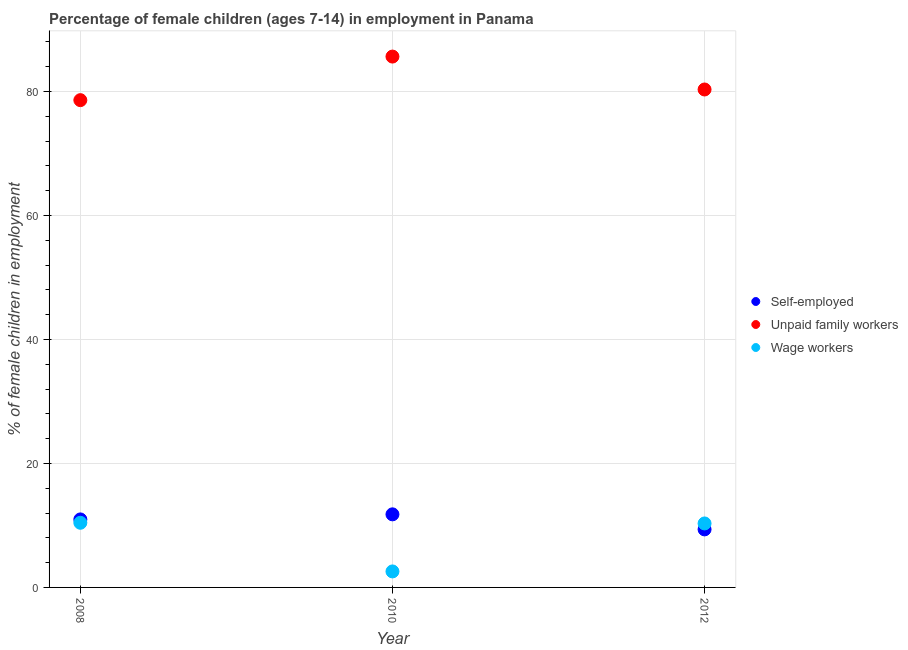What is the percentage of self employed children in 2008?
Offer a very short reply. 10.97. Across all years, what is the maximum percentage of children employed as wage workers?
Your response must be concise. 10.43. Across all years, what is the minimum percentage of self employed children?
Your response must be concise. 9.36. In which year was the percentage of self employed children maximum?
Your answer should be very brief. 2010. In which year was the percentage of children employed as unpaid family workers minimum?
Keep it short and to the point. 2008. What is the total percentage of children employed as unpaid family workers in the graph?
Keep it short and to the point. 244.55. What is the difference between the percentage of children employed as unpaid family workers in 2008 and that in 2012?
Ensure brevity in your answer.  -1.72. What is the difference between the percentage of children employed as wage workers in 2010 and the percentage of self employed children in 2012?
Offer a very short reply. -6.78. What is the average percentage of self employed children per year?
Ensure brevity in your answer.  10.71. In the year 2008, what is the difference between the percentage of self employed children and percentage of children employed as unpaid family workers?
Your answer should be compact. -67.63. What is the ratio of the percentage of children employed as wage workers in 2008 to that in 2010?
Keep it short and to the point. 4.04. What is the difference between the highest and the second highest percentage of self employed children?
Keep it short and to the point. 0.82. What is the difference between the highest and the lowest percentage of self employed children?
Keep it short and to the point. 2.43. In how many years, is the percentage of children employed as wage workers greater than the average percentage of children employed as wage workers taken over all years?
Provide a short and direct response. 2. Does the percentage of self employed children monotonically increase over the years?
Offer a terse response. No. How many dotlines are there?
Give a very brief answer. 3. How many years are there in the graph?
Offer a very short reply. 3. What is the difference between two consecutive major ticks on the Y-axis?
Offer a very short reply. 20. Does the graph contain any zero values?
Your answer should be very brief. No. Where does the legend appear in the graph?
Your response must be concise. Center right. How many legend labels are there?
Your response must be concise. 3. How are the legend labels stacked?
Your response must be concise. Vertical. What is the title of the graph?
Make the answer very short. Percentage of female children (ages 7-14) in employment in Panama. Does "Coal" appear as one of the legend labels in the graph?
Offer a very short reply. No. What is the label or title of the X-axis?
Offer a very short reply. Year. What is the label or title of the Y-axis?
Your answer should be very brief. % of female children in employment. What is the % of female children in employment of Self-employed in 2008?
Provide a short and direct response. 10.97. What is the % of female children in employment in Unpaid family workers in 2008?
Your answer should be compact. 78.6. What is the % of female children in employment in Wage workers in 2008?
Make the answer very short. 10.43. What is the % of female children in employment in Self-employed in 2010?
Your response must be concise. 11.79. What is the % of female children in employment of Unpaid family workers in 2010?
Your answer should be compact. 85.63. What is the % of female children in employment in Wage workers in 2010?
Your answer should be very brief. 2.58. What is the % of female children in employment of Self-employed in 2012?
Make the answer very short. 9.36. What is the % of female children in employment of Unpaid family workers in 2012?
Keep it short and to the point. 80.32. What is the % of female children in employment of Wage workers in 2012?
Your answer should be very brief. 10.32. Across all years, what is the maximum % of female children in employment of Self-employed?
Offer a terse response. 11.79. Across all years, what is the maximum % of female children in employment of Unpaid family workers?
Your response must be concise. 85.63. Across all years, what is the maximum % of female children in employment in Wage workers?
Give a very brief answer. 10.43. Across all years, what is the minimum % of female children in employment of Self-employed?
Provide a short and direct response. 9.36. Across all years, what is the minimum % of female children in employment in Unpaid family workers?
Provide a short and direct response. 78.6. Across all years, what is the minimum % of female children in employment of Wage workers?
Provide a succinct answer. 2.58. What is the total % of female children in employment in Self-employed in the graph?
Provide a short and direct response. 32.12. What is the total % of female children in employment of Unpaid family workers in the graph?
Offer a very short reply. 244.55. What is the total % of female children in employment in Wage workers in the graph?
Your response must be concise. 23.33. What is the difference between the % of female children in employment in Self-employed in 2008 and that in 2010?
Your answer should be very brief. -0.82. What is the difference between the % of female children in employment in Unpaid family workers in 2008 and that in 2010?
Your answer should be compact. -7.03. What is the difference between the % of female children in employment of Wage workers in 2008 and that in 2010?
Ensure brevity in your answer.  7.85. What is the difference between the % of female children in employment in Self-employed in 2008 and that in 2012?
Provide a succinct answer. 1.61. What is the difference between the % of female children in employment of Unpaid family workers in 2008 and that in 2012?
Your response must be concise. -1.72. What is the difference between the % of female children in employment in Wage workers in 2008 and that in 2012?
Your answer should be very brief. 0.11. What is the difference between the % of female children in employment in Self-employed in 2010 and that in 2012?
Ensure brevity in your answer.  2.43. What is the difference between the % of female children in employment in Unpaid family workers in 2010 and that in 2012?
Your answer should be compact. 5.31. What is the difference between the % of female children in employment of Wage workers in 2010 and that in 2012?
Keep it short and to the point. -7.74. What is the difference between the % of female children in employment in Self-employed in 2008 and the % of female children in employment in Unpaid family workers in 2010?
Your answer should be compact. -74.66. What is the difference between the % of female children in employment in Self-employed in 2008 and the % of female children in employment in Wage workers in 2010?
Give a very brief answer. 8.39. What is the difference between the % of female children in employment in Unpaid family workers in 2008 and the % of female children in employment in Wage workers in 2010?
Your answer should be very brief. 76.02. What is the difference between the % of female children in employment in Self-employed in 2008 and the % of female children in employment in Unpaid family workers in 2012?
Your answer should be compact. -69.35. What is the difference between the % of female children in employment in Self-employed in 2008 and the % of female children in employment in Wage workers in 2012?
Provide a succinct answer. 0.65. What is the difference between the % of female children in employment in Unpaid family workers in 2008 and the % of female children in employment in Wage workers in 2012?
Your answer should be compact. 68.28. What is the difference between the % of female children in employment in Self-employed in 2010 and the % of female children in employment in Unpaid family workers in 2012?
Make the answer very short. -68.53. What is the difference between the % of female children in employment in Self-employed in 2010 and the % of female children in employment in Wage workers in 2012?
Give a very brief answer. 1.47. What is the difference between the % of female children in employment in Unpaid family workers in 2010 and the % of female children in employment in Wage workers in 2012?
Ensure brevity in your answer.  75.31. What is the average % of female children in employment of Self-employed per year?
Provide a short and direct response. 10.71. What is the average % of female children in employment in Unpaid family workers per year?
Ensure brevity in your answer.  81.52. What is the average % of female children in employment in Wage workers per year?
Offer a terse response. 7.78. In the year 2008, what is the difference between the % of female children in employment in Self-employed and % of female children in employment in Unpaid family workers?
Give a very brief answer. -67.63. In the year 2008, what is the difference between the % of female children in employment of Self-employed and % of female children in employment of Wage workers?
Your response must be concise. 0.54. In the year 2008, what is the difference between the % of female children in employment of Unpaid family workers and % of female children in employment of Wage workers?
Make the answer very short. 68.17. In the year 2010, what is the difference between the % of female children in employment in Self-employed and % of female children in employment in Unpaid family workers?
Offer a very short reply. -73.84. In the year 2010, what is the difference between the % of female children in employment of Self-employed and % of female children in employment of Wage workers?
Your answer should be compact. 9.21. In the year 2010, what is the difference between the % of female children in employment of Unpaid family workers and % of female children in employment of Wage workers?
Make the answer very short. 83.05. In the year 2012, what is the difference between the % of female children in employment of Self-employed and % of female children in employment of Unpaid family workers?
Your answer should be compact. -70.96. In the year 2012, what is the difference between the % of female children in employment of Self-employed and % of female children in employment of Wage workers?
Offer a terse response. -0.96. What is the ratio of the % of female children in employment of Self-employed in 2008 to that in 2010?
Ensure brevity in your answer.  0.93. What is the ratio of the % of female children in employment in Unpaid family workers in 2008 to that in 2010?
Your response must be concise. 0.92. What is the ratio of the % of female children in employment of Wage workers in 2008 to that in 2010?
Provide a succinct answer. 4.04. What is the ratio of the % of female children in employment of Self-employed in 2008 to that in 2012?
Ensure brevity in your answer.  1.17. What is the ratio of the % of female children in employment of Unpaid family workers in 2008 to that in 2012?
Offer a terse response. 0.98. What is the ratio of the % of female children in employment of Wage workers in 2008 to that in 2012?
Provide a succinct answer. 1.01. What is the ratio of the % of female children in employment of Self-employed in 2010 to that in 2012?
Offer a very short reply. 1.26. What is the ratio of the % of female children in employment in Unpaid family workers in 2010 to that in 2012?
Give a very brief answer. 1.07. What is the ratio of the % of female children in employment in Wage workers in 2010 to that in 2012?
Give a very brief answer. 0.25. What is the difference between the highest and the second highest % of female children in employment of Self-employed?
Offer a terse response. 0.82. What is the difference between the highest and the second highest % of female children in employment of Unpaid family workers?
Give a very brief answer. 5.31. What is the difference between the highest and the second highest % of female children in employment of Wage workers?
Keep it short and to the point. 0.11. What is the difference between the highest and the lowest % of female children in employment in Self-employed?
Ensure brevity in your answer.  2.43. What is the difference between the highest and the lowest % of female children in employment in Unpaid family workers?
Provide a succinct answer. 7.03. What is the difference between the highest and the lowest % of female children in employment in Wage workers?
Keep it short and to the point. 7.85. 